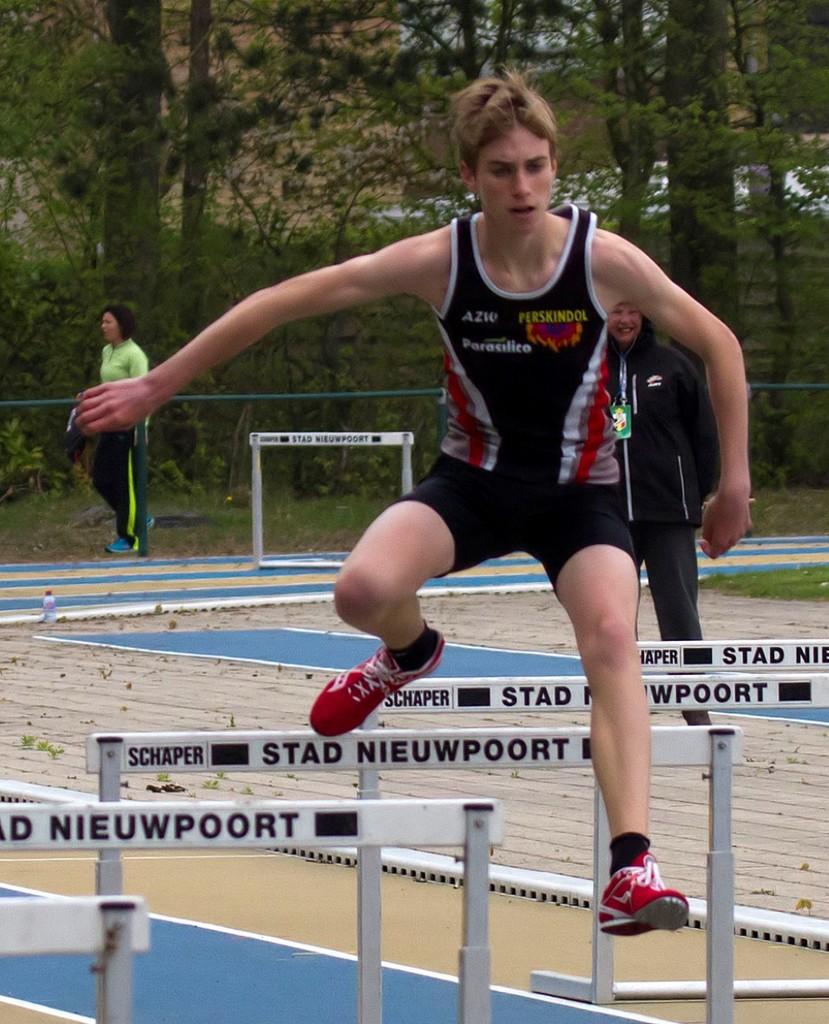What foreign words are on the things that he is jumping over?
Your response must be concise. Stad nieuwpoort. What color is the text on the thing that he is jumping over?
Offer a terse response. Black. 